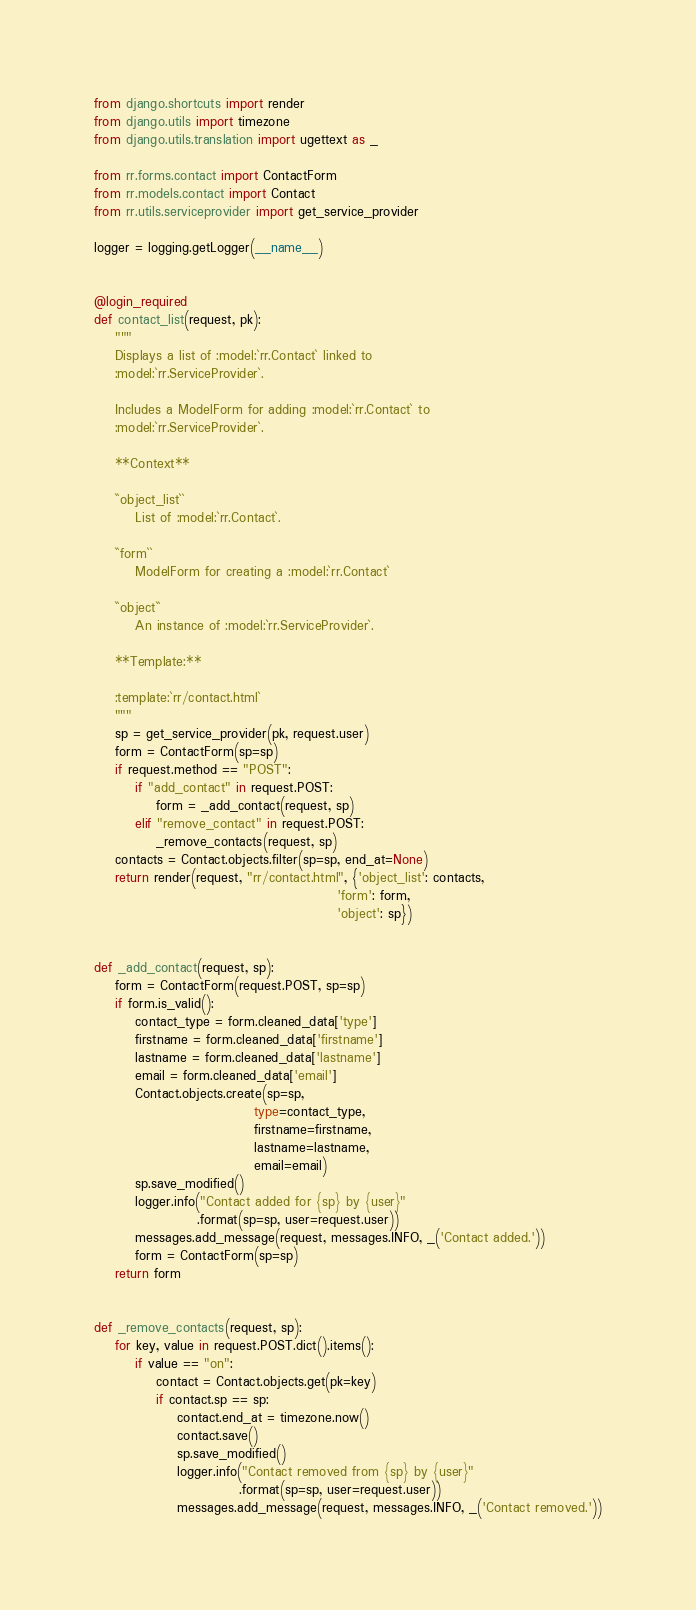<code> <loc_0><loc_0><loc_500><loc_500><_Python_>from django.shortcuts import render
from django.utils import timezone
from django.utils.translation import ugettext as _

from rr.forms.contact import ContactForm
from rr.models.contact import Contact
from rr.utils.serviceprovider import get_service_provider

logger = logging.getLogger(__name__)


@login_required
def contact_list(request, pk):
    """
    Displays a list of :model:`rr.Contact` linked to
    :model:`rr.ServiceProvider`.

    Includes a ModelForm for adding :model:`rr.Contact` to
    :model:`rr.ServiceProvider`.

    **Context**

    ``object_list``
        List of :model:`rr.Contact`.

    ``form``
        ModelForm for creating a :model:`rr.Contact`

    ``object``
        An instance of :model:`rr.ServiceProvider`.

    **Template:**

    :template:`rr/contact.html`
    """
    sp = get_service_provider(pk, request.user)
    form = ContactForm(sp=sp)
    if request.method == "POST":
        if "add_contact" in request.POST:
            form = _add_contact(request, sp)
        elif "remove_contact" in request.POST:
            _remove_contacts(request, sp)
    contacts = Contact.objects.filter(sp=sp, end_at=None)
    return render(request, "rr/contact.html", {'object_list': contacts,
                                               'form': form,
                                               'object': sp})


def _add_contact(request, sp):
    form = ContactForm(request.POST, sp=sp)
    if form.is_valid():
        contact_type = form.cleaned_data['type']
        firstname = form.cleaned_data['firstname']
        lastname = form.cleaned_data['lastname']
        email = form.cleaned_data['email']
        Contact.objects.create(sp=sp,
                               type=contact_type,
                               firstname=firstname,
                               lastname=lastname,
                               email=email)
        sp.save_modified()
        logger.info("Contact added for {sp} by {user}"
                    .format(sp=sp, user=request.user))
        messages.add_message(request, messages.INFO, _('Contact added.'))
        form = ContactForm(sp=sp)
    return form


def _remove_contacts(request, sp):
    for key, value in request.POST.dict().items():
        if value == "on":
            contact = Contact.objects.get(pk=key)
            if contact.sp == sp:
                contact.end_at = timezone.now()
                contact.save()
                sp.save_modified()
                logger.info("Contact removed from {sp} by {user}"
                            .format(sp=sp, user=request.user))
                messages.add_message(request, messages.INFO, _('Contact removed.'))</code> 